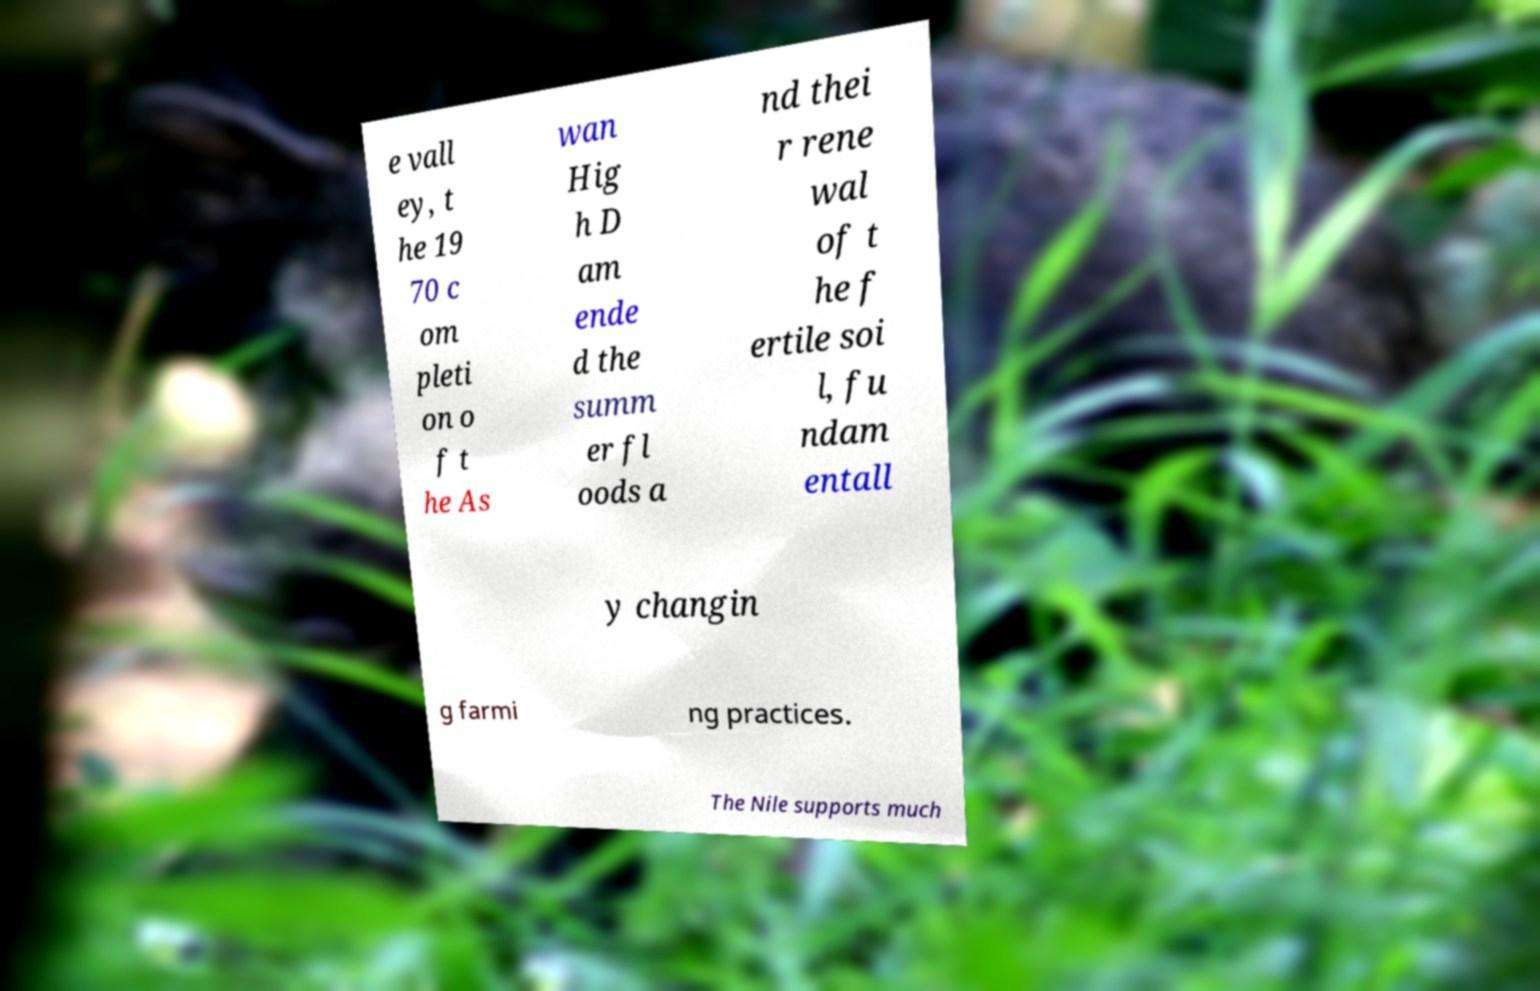Could you extract and type out the text from this image? e vall ey, t he 19 70 c om pleti on o f t he As wan Hig h D am ende d the summ er fl oods a nd thei r rene wal of t he f ertile soi l, fu ndam entall y changin g farmi ng practices. The Nile supports much 